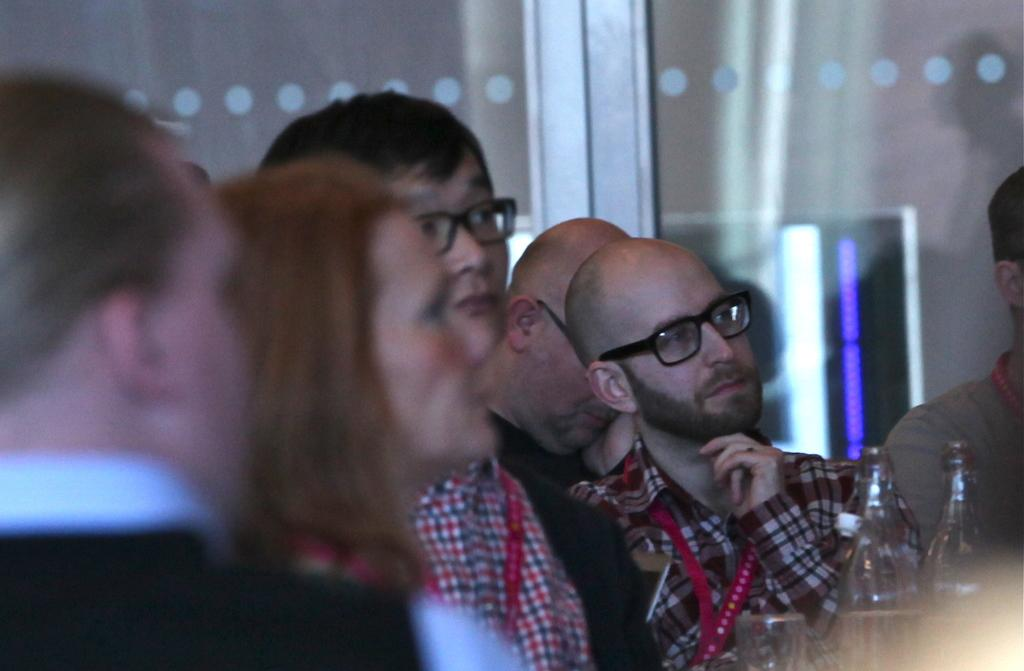What is located in the foreground of the image? There are people in the foreground of the image. What objects can be seen in the right corner of the image? There are bottles and glasses in the right corner of the image. What type of door is visible in the background of the image? There is a glass door in the background of the image. How does the earthquake affect the people in the image? There is no earthquake present in the image, so its effects cannot be observed. What type of hope is depicted in the image? There is no depiction of hope in the image; it features people, bottles, glasses, and a glass door. 